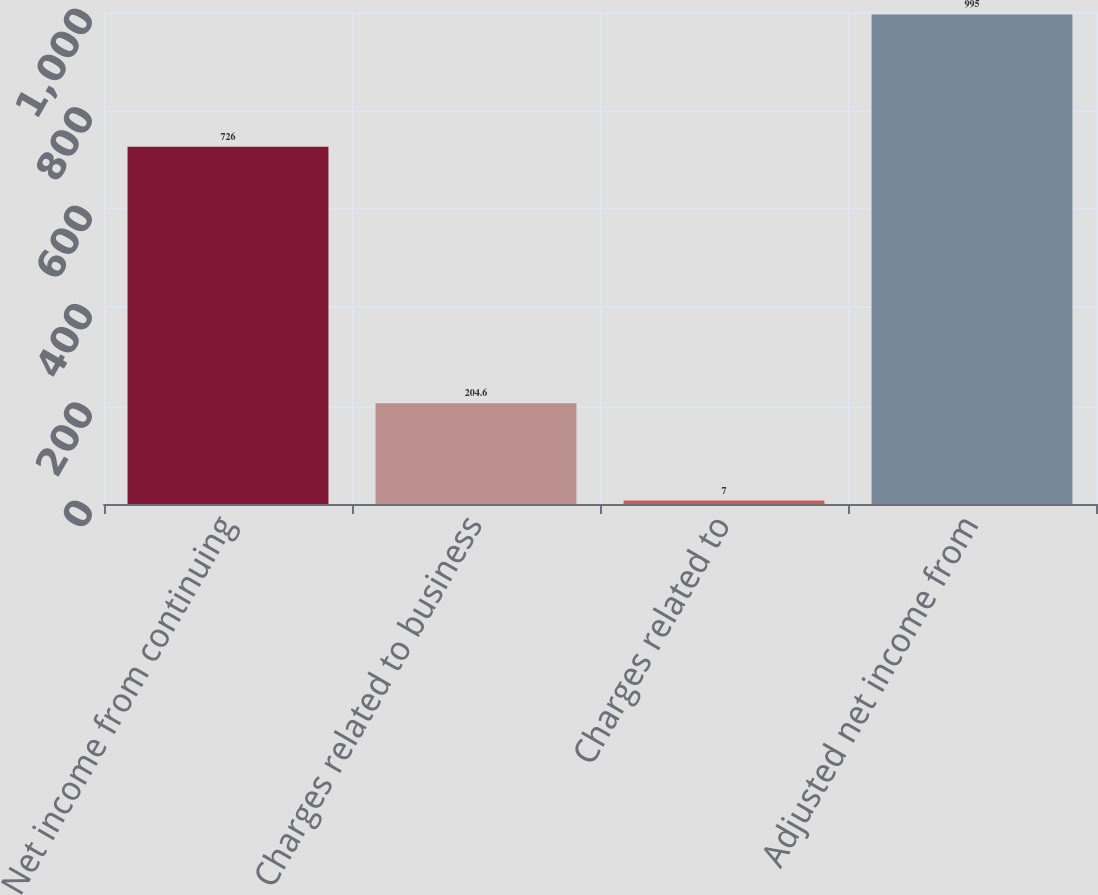Convert chart to OTSL. <chart><loc_0><loc_0><loc_500><loc_500><bar_chart><fcel>Net income from continuing<fcel>Charges related to business<fcel>Charges related to<fcel>Adjusted net income from<nl><fcel>726<fcel>204.6<fcel>7<fcel>995<nl></chart> 